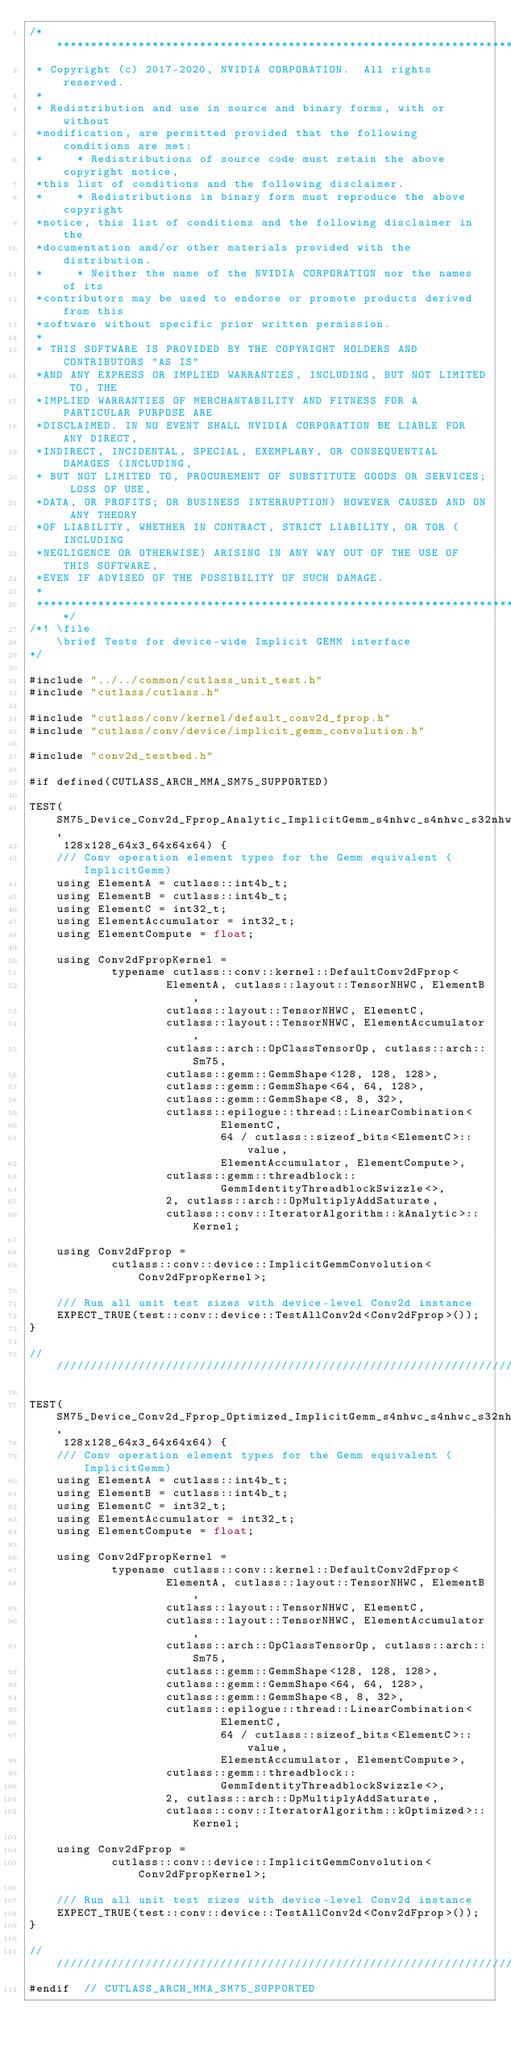Convert code to text. <code><loc_0><loc_0><loc_500><loc_500><_Cuda_>/***************************************************************************************************
 * Copyright (c) 2017-2020, NVIDIA CORPORATION.  All rights reserved.
 *
 * Redistribution and use in source and binary forms, with or without
 *modification, are permitted provided that the following conditions are met:
 *     * Redistributions of source code must retain the above copyright notice,
 *this list of conditions and the following disclaimer.
 *     * Redistributions in binary form must reproduce the above copyright
 *notice, this list of conditions and the following disclaimer in the
 *documentation and/or other materials provided with the distribution.
 *     * Neither the name of the NVIDIA CORPORATION nor the names of its
 *contributors may be used to endorse or promote products derived from this
 *software without specific prior written permission.
 *
 * THIS SOFTWARE IS PROVIDED BY THE COPYRIGHT HOLDERS AND CONTRIBUTORS "AS IS"
 *AND ANY EXPRESS OR IMPLIED WARRANTIES, INCLUDING, BUT NOT LIMITED TO, THE
 *IMPLIED WARRANTIES OF MERCHANTABILITY AND FITNESS FOR A PARTICULAR PURPOSE ARE
 *DISCLAIMED. IN NO EVENT SHALL NVIDIA CORPORATION BE LIABLE FOR ANY DIRECT,
 *INDIRECT, INCIDENTAL, SPECIAL, EXEMPLARY, OR CONSEQUENTIAL DAMAGES (INCLUDING,
 * BUT NOT LIMITED TO, PROCUREMENT OF SUBSTITUTE GOODS OR SERVICES; LOSS OF USE,
 *DATA, OR PROFITS; OR BUSINESS INTERRUPTION) HOWEVER CAUSED AND ON ANY THEORY
 *OF LIABILITY, WHETHER IN CONTRACT, STRICT LIABILITY, OR TOR (INCLUDING
 *NEGLIGENCE OR OTHERWISE) ARISING IN ANY WAY OUT OF THE USE OF THIS SOFTWARE,
 *EVEN IF ADVISED OF THE POSSIBILITY OF SUCH DAMAGE.
 *
 **************************************************************************************************/
/*! \file
    \brief Tests for device-wide Implicit GEMM interface
*/

#include "../../common/cutlass_unit_test.h"
#include "cutlass/cutlass.h"

#include "cutlass/conv/kernel/default_conv2d_fprop.h"
#include "cutlass/conv/device/implicit_gemm_convolution.h"

#include "conv2d_testbed.h"

#if defined(CUTLASS_ARCH_MMA_SM75_SUPPORTED)

TEST(SM75_Device_Conv2d_Fprop_Analytic_ImplicitGemm_s4nhwc_s4nhwc_s32nhwc_tensor_op_s32,
     128x128_64x3_64x64x64) {
    /// Conv operation element types for the Gemm equivalent (ImplicitGemm)
    using ElementA = cutlass::int4b_t;
    using ElementB = cutlass::int4b_t;
    using ElementC = int32_t;
    using ElementAccumulator = int32_t;
    using ElementCompute = float;

    using Conv2dFpropKernel =
            typename cutlass::conv::kernel::DefaultConv2dFprop<
                    ElementA, cutlass::layout::TensorNHWC, ElementB,
                    cutlass::layout::TensorNHWC, ElementC,
                    cutlass::layout::TensorNHWC, ElementAccumulator,
                    cutlass::arch::OpClassTensorOp, cutlass::arch::Sm75,
                    cutlass::gemm::GemmShape<128, 128, 128>,
                    cutlass::gemm::GemmShape<64, 64, 128>,
                    cutlass::gemm::GemmShape<8, 8, 32>,
                    cutlass::epilogue::thread::LinearCombination<
                            ElementC,
                            64 / cutlass::sizeof_bits<ElementC>::value,
                            ElementAccumulator, ElementCompute>,
                    cutlass::gemm::threadblock::
                            GemmIdentityThreadblockSwizzle<>,
                    2, cutlass::arch::OpMultiplyAddSaturate,
                    cutlass::conv::IteratorAlgorithm::kAnalytic>::Kernel;

    using Conv2dFprop =
            cutlass::conv::device::ImplicitGemmConvolution<Conv2dFpropKernel>;

    /// Run all unit test sizes with device-level Conv2d instance
    EXPECT_TRUE(test::conv::device::TestAllConv2d<Conv2dFprop>());
}

////////////////////////////////////////////////////////////////////////////////

TEST(SM75_Device_Conv2d_Fprop_Optimized_ImplicitGemm_s4nhwc_s4nhwc_s32nhwc_tensor_op_s32,
     128x128_64x3_64x64x64) {
    /// Conv operation element types for the Gemm equivalent (ImplicitGemm)
    using ElementA = cutlass::int4b_t;
    using ElementB = cutlass::int4b_t;
    using ElementC = int32_t;
    using ElementAccumulator = int32_t;
    using ElementCompute = float;

    using Conv2dFpropKernel =
            typename cutlass::conv::kernel::DefaultConv2dFprop<
                    ElementA, cutlass::layout::TensorNHWC, ElementB,
                    cutlass::layout::TensorNHWC, ElementC,
                    cutlass::layout::TensorNHWC, ElementAccumulator,
                    cutlass::arch::OpClassTensorOp, cutlass::arch::Sm75,
                    cutlass::gemm::GemmShape<128, 128, 128>,
                    cutlass::gemm::GemmShape<64, 64, 128>,
                    cutlass::gemm::GemmShape<8, 8, 32>,
                    cutlass::epilogue::thread::LinearCombination<
                            ElementC,
                            64 / cutlass::sizeof_bits<ElementC>::value,
                            ElementAccumulator, ElementCompute>,
                    cutlass::gemm::threadblock::
                            GemmIdentityThreadblockSwizzle<>,
                    2, cutlass::arch::OpMultiplyAddSaturate,
                    cutlass::conv::IteratorAlgorithm::kOptimized>::Kernel;

    using Conv2dFprop =
            cutlass::conv::device::ImplicitGemmConvolution<Conv2dFpropKernel>;

    /// Run all unit test sizes with device-level Conv2d instance
    EXPECT_TRUE(test::conv::device::TestAllConv2d<Conv2dFprop>());
}

////////////////////////////////////////////////////////////////////////////////
#endif  // CUTLASS_ARCH_MMA_SM75_SUPPORTED
</code> 